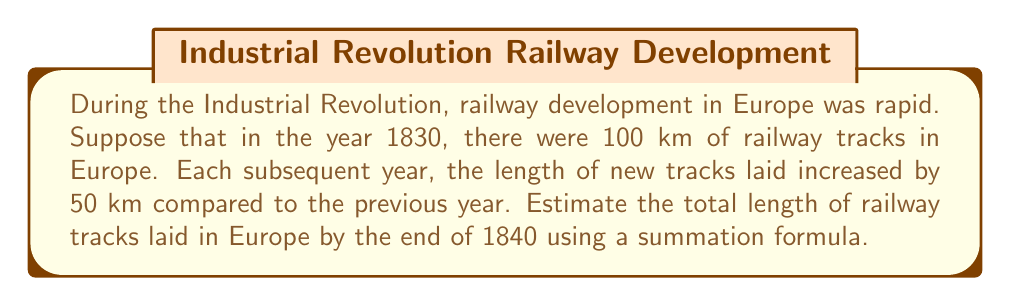Could you help me with this problem? Let's approach this step-by-step:

1) First, we need to identify the arithmetic sequence for the new tracks laid each year:
   Year 1 (1830): 100 km
   Year 2 (1831): 100 + 50 = 150 km
   Year 3 (1832): 150 + 50 = 200 km
   And so on...

2) We can represent this as an arithmetic sequence with:
   $a_1 = 100$ (first term)
   $d = 50$ (common difference)

3) The sum of an arithmetic sequence is given by the formula:
   $$S_n = \frac{n}{2}(a_1 + a_n)$$
   Where $n$ is the number of terms, $a_1$ is the first term, and $a_n$ is the last term.

4) We need to find $a_n$ for the 11th term (as we're summing from 1830 to 1840, inclusive):
   $a_n = a_1 + (n-1)d$
   $a_{11} = 100 + (11-1)50 = 100 + 500 = 600$

5) Now we can apply the summation formula:
   $$S_{11} = \frac{11}{2}(100 + 600) = \frac{11}{2}(700) = 3850$$

6) Therefore, the total length of railway tracks laid by the end of 1840 is estimated to be 3850 km.
Answer: 3850 km 